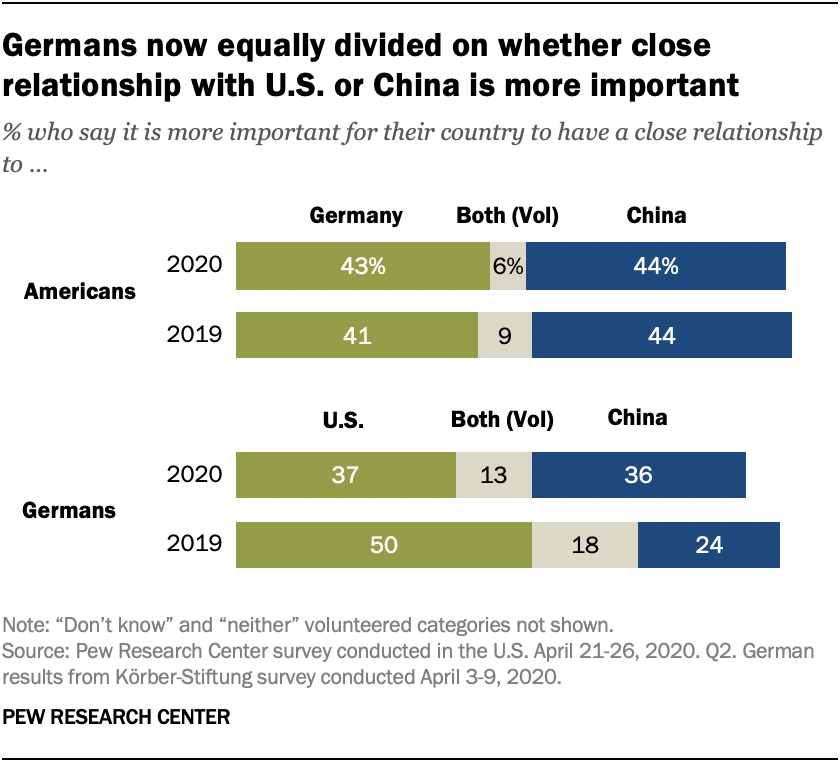List a handful of essential elements in this visual. The median of all the blue bars is not greater than the largest value of the green bar. In 2019, the value of the green bar was 50. 